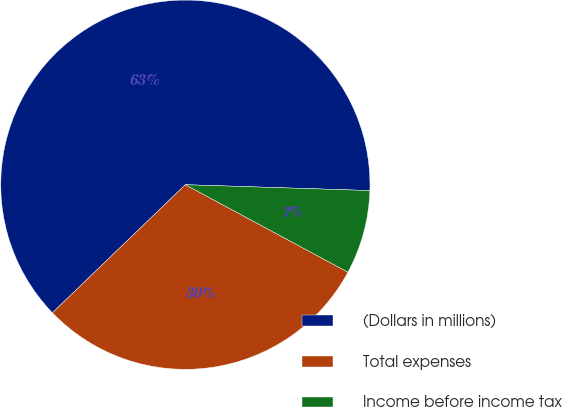Convert chart to OTSL. <chart><loc_0><loc_0><loc_500><loc_500><pie_chart><fcel>(Dollars in millions)<fcel>Total expenses<fcel>Income before income tax<nl><fcel>62.71%<fcel>29.94%<fcel>7.35%<nl></chart> 